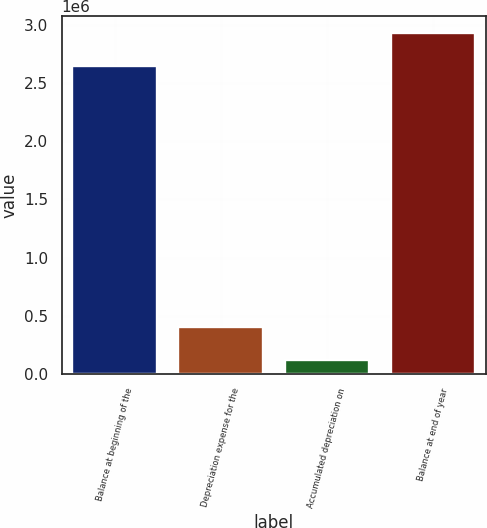Convert chart to OTSL. <chart><loc_0><loc_0><loc_500><loc_500><bar_chart><fcel>Balance at beginning of the<fcel>Depreciation expense for the<fcel>Accumulated depreciation on<fcel>Balance at end of year<nl><fcel>2.64687e+06<fcel>402300<fcel>122153<fcel>2.92702e+06<nl></chart> 